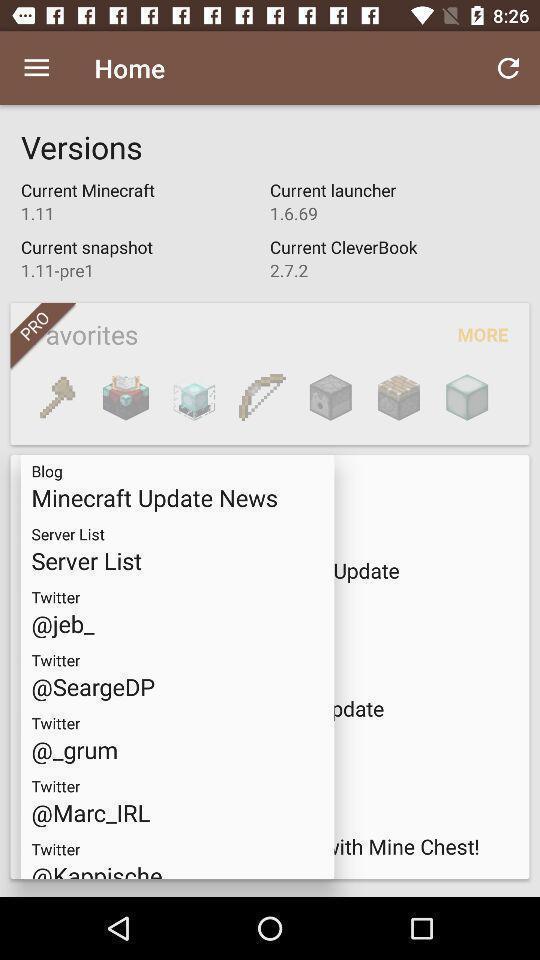What is the overall content of this screenshot? Screen displaying home page. 